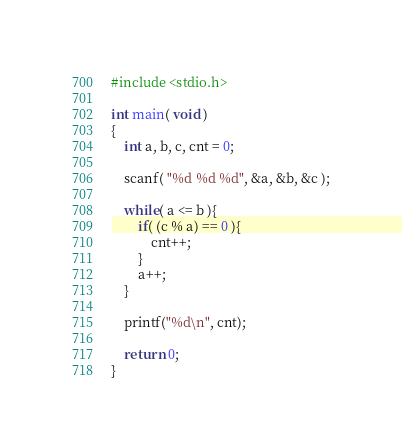<code> <loc_0><loc_0><loc_500><loc_500><_C_>#include <stdio.h>

int main( void )
{
	int a, b, c, cnt = 0;
	
	scanf( "%d %d %d", &a, &b, &c );
	
	while( a <= b ){
		if( (c % a) == 0 ){
			cnt++;
		}
		a++;
	}
	
	printf("%d\n", cnt);
	
	return 0;
}</code> 